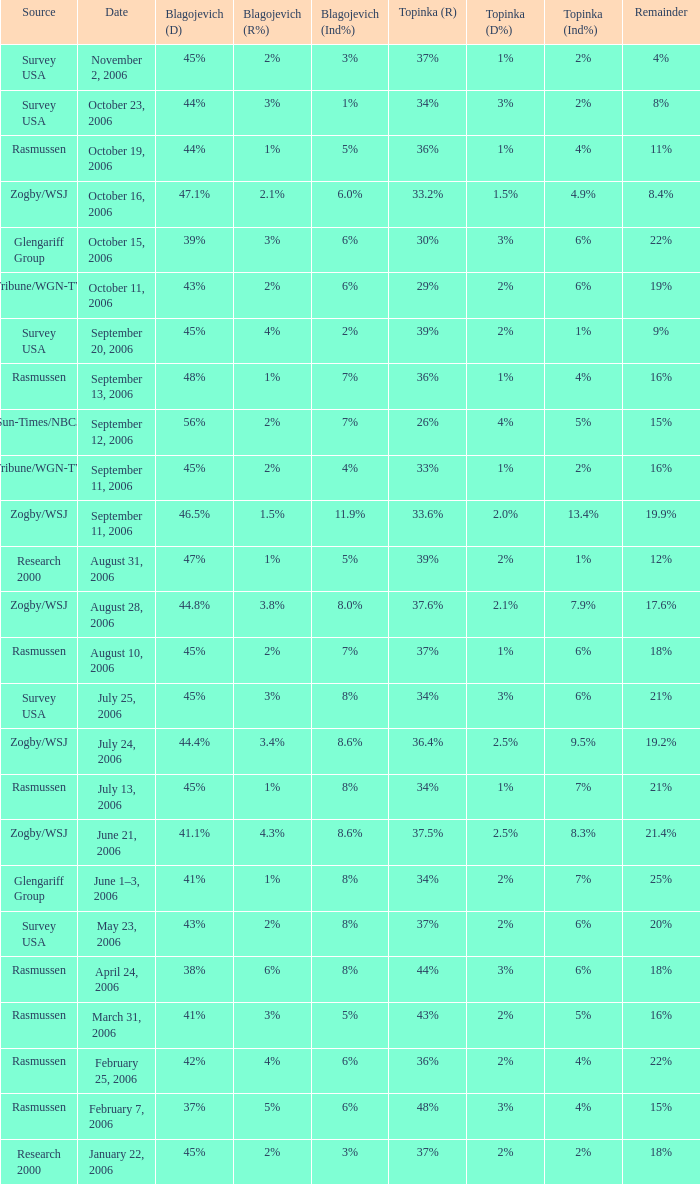Which Date has a Remainder of 20%? May 23, 2006. 